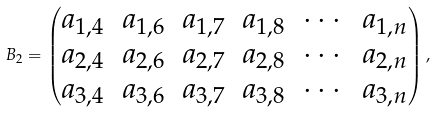Convert formula to latex. <formula><loc_0><loc_0><loc_500><loc_500>B _ { 2 } = \begin{pmatrix} a _ { 1 , 4 } & a _ { 1 , 6 } & a _ { 1 , 7 } & a _ { 1 , 8 } & \cdots & a _ { 1 , n } \\ a _ { 2 , 4 } & a _ { 2 , 6 } & a _ { 2 , 7 } & a _ { 2 , 8 } & \cdots & a _ { 2 , n } \\ a _ { 3 , 4 } & a _ { 3 , 6 } & a _ { 3 , 7 } & a _ { 3 , 8 } & \cdots & a _ { 3 , n } \end{pmatrix} ,</formula> 